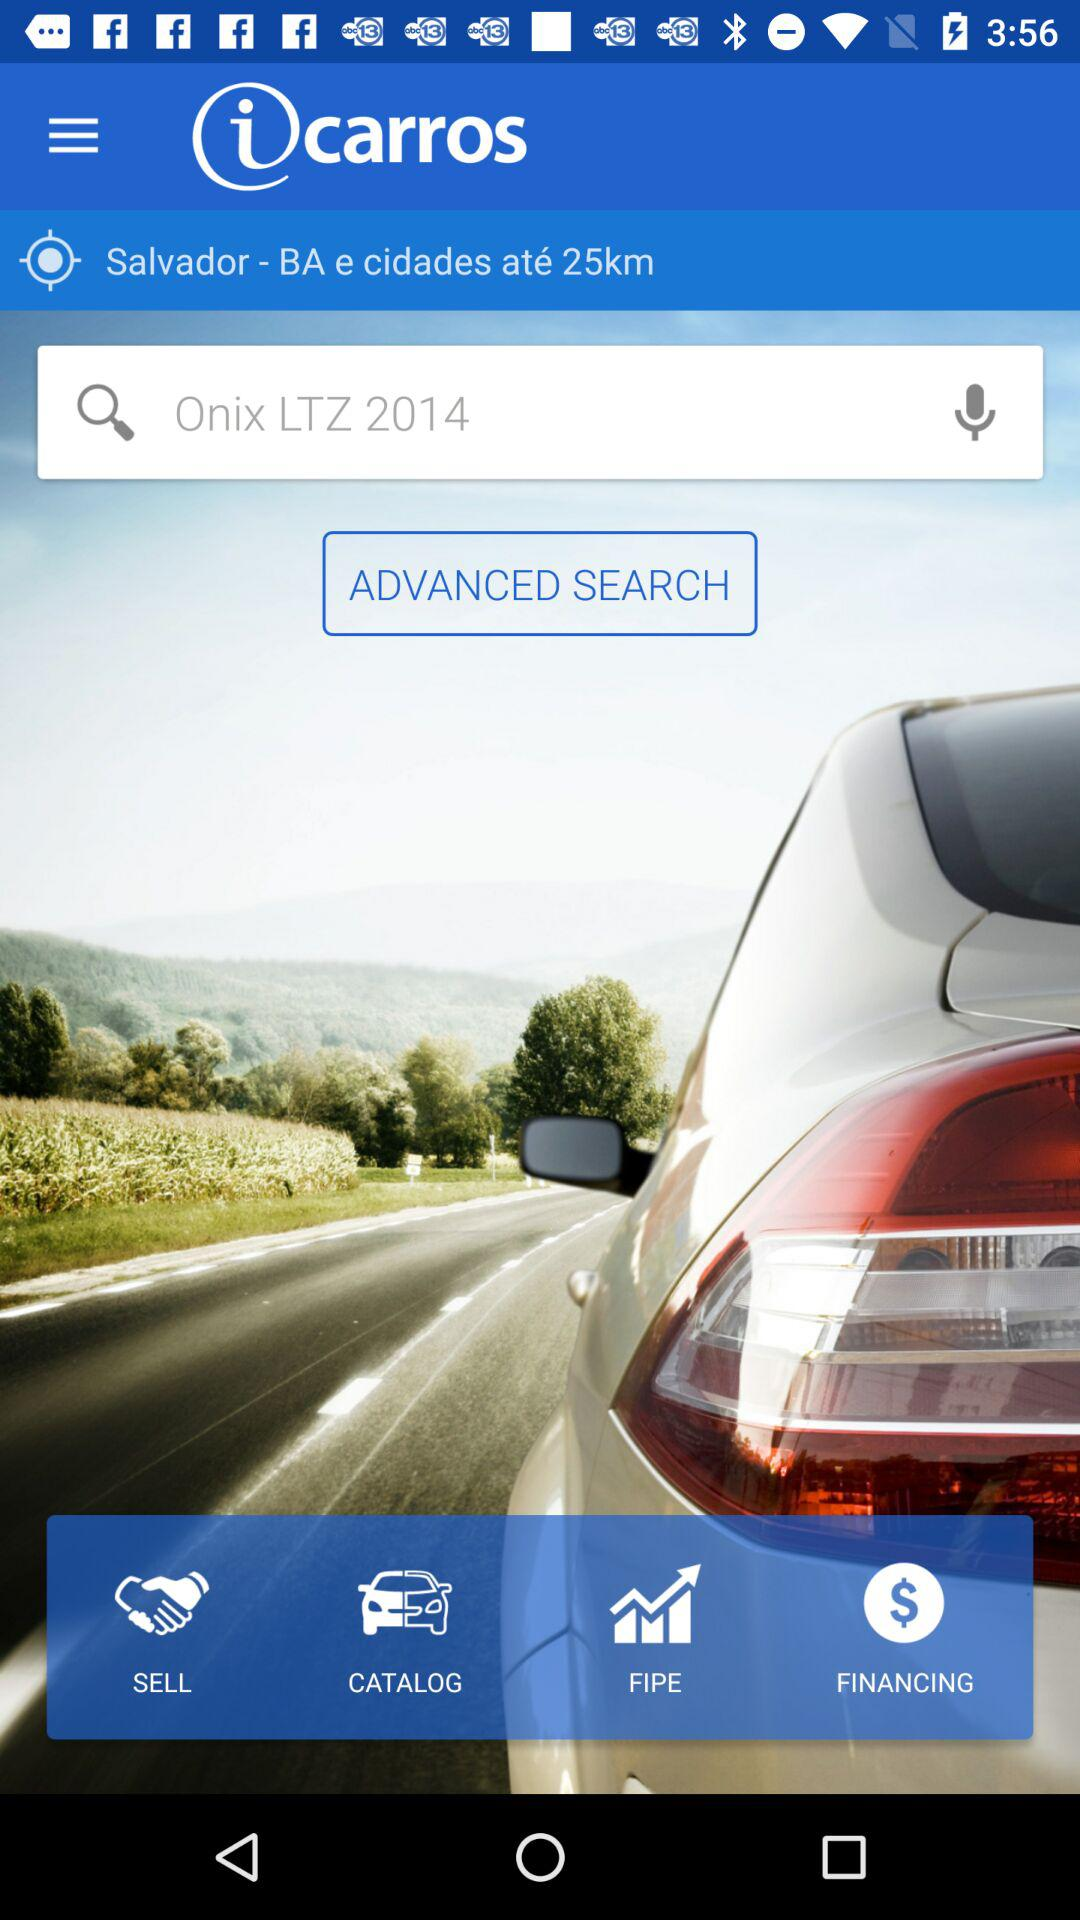What is the application name? The application name is "iCarros". 